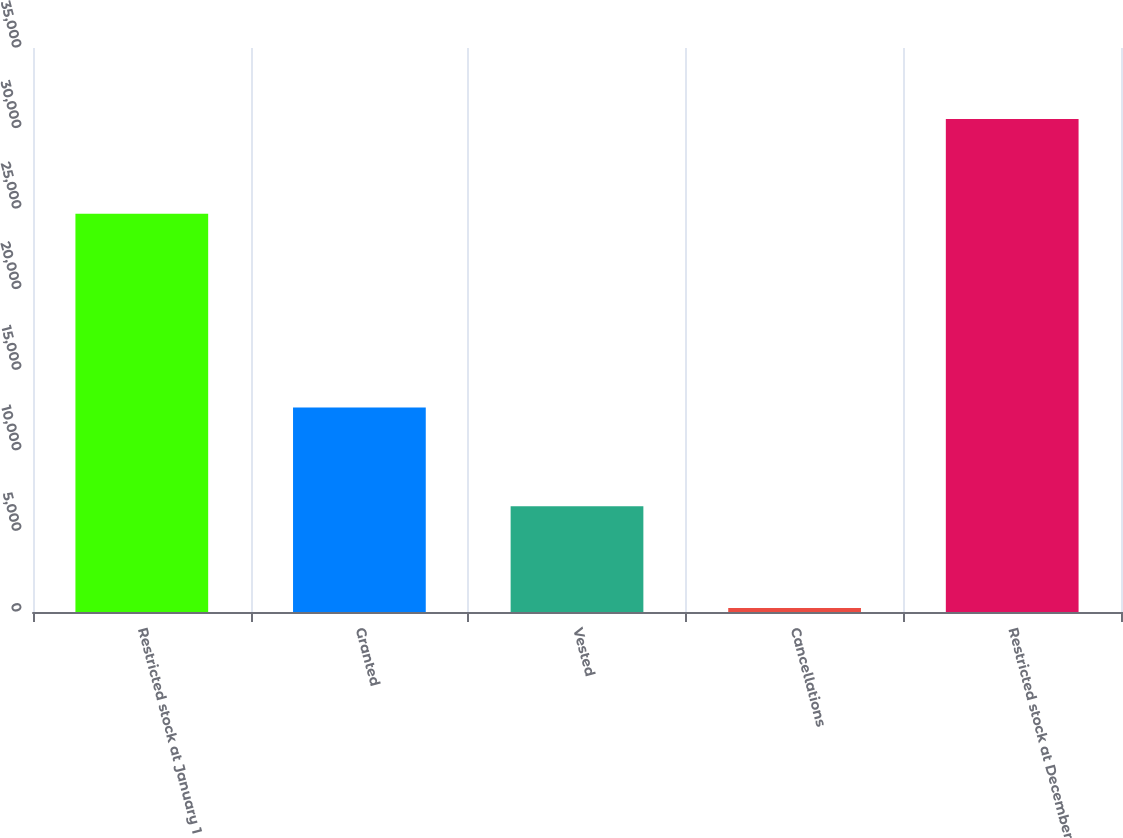Convert chart. <chart><loc_0><loc_0><loc_500><loc_500><bar_chart><fcel>Restricted stock at January 1<fcel>Granted<fcel>Vested<fcel>Cancellations<fcel>Restricted stock at December<nl><fcel>24718<fcel>12693<fcel>6563<fcel>248<fcel>30600<nl></chart> 